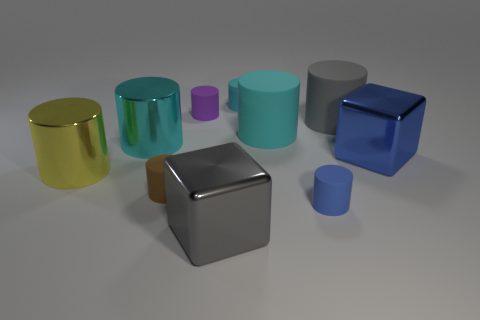There is a gray thing behind the yellow object; what is its material?
Your response must be concise. Rubber. What material is the small cyan thing?
Offer a terse response. Rubber. What is the cylinder on the left side of the big shiny cylinder that is behind the big shiny object right of the large gray metallic thing made of?
Make the answer very short. Metal. There is a yellow object; does it have the same size as the purple matte object that is behind the tiny brown cylinder?
Give a very brief answer. No. How many things are either blue cylinders on the right side of the large yellow thing or cylinders on the right side of the gray block?
Ensure brevity in your answer.  4. There is a tiny cylinder that is left of the purple rubber thing; what is its color?
Your answer should be very brief. Brown. Are there any small cyan cylinders in front of the big cube that is on the right side of the tiny blue rubber object?
Provide a short and direct response. No. Is the number of tiny cyan things less than the number of tiny cyan metal cubes?
Your response must be concise. No. What is the material of the cyan cylinder that is to the left of the matte object that is left of the purple thing?
Provide a succinct answer. Metal. Does the brown rubber cylinder have the same size as the cyan metallic cylinder?
Make the answer very short. No. 